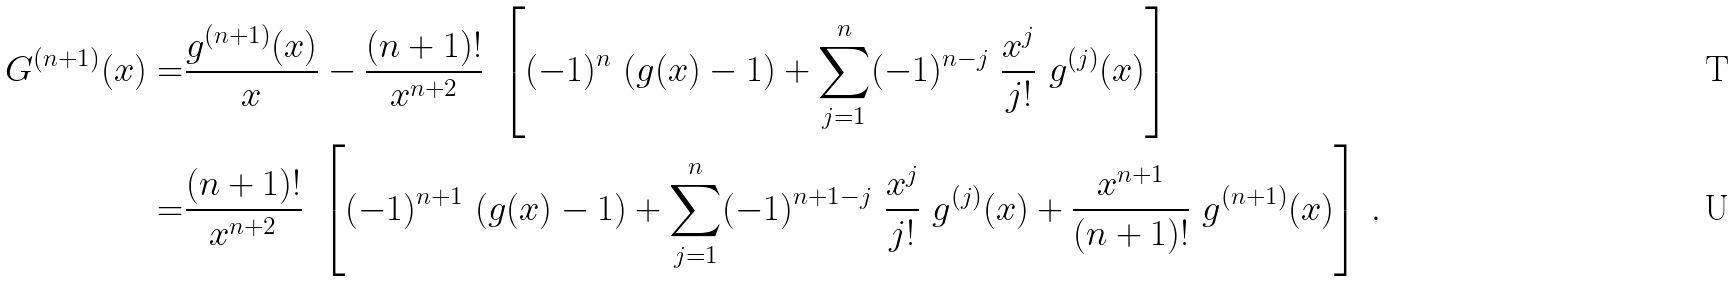<formula> <loc_0><loc_0><loc_500><loc_500>G ^ { ( n + 1 ) } ( x ) = & \frac { g ^ { ( n + 1 ) } ( x ) } { x } - \frac { ( n + 1 ) ! } { x ^ { n + 2 } } \ \left [ ( - 1 ) ^ { n } \ ( g ( x ) - 1 ) + \sum _ { j = 1 } ^ { n } ( - 1 ) ^ { n - j } \ \frac { x ^ { j } } { j ! } \ g ^ { ( j ) } ( x ) \right ] \\ = & \frac { ( n + 1 ) ! } { x ^ { n + 2 } } \ \left [ ( - 1 ) ^ { n + 1 } \ ( g ( x ) - 1 ) + \sum _ { j = 1 } ^ { n } ( - 1 ) ^ { n + 1 - j } \ \frac { x ^ { j } } { j ! } \ g ^ { ( j ) } ( x ) + \frac { x ^ { n + 1 } } { ( n + 1 ) ! } \ g ^ { ( n + 1 ) } ( x ) \right ] \, .</formula> 